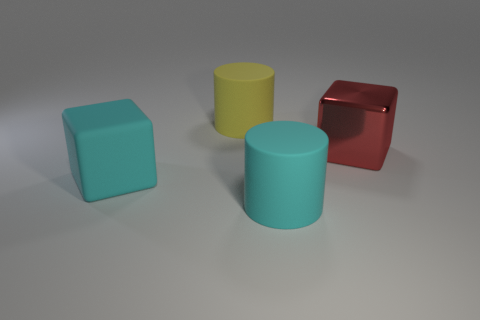Subtract 1 blocks. How many blocks are left? 1 Subtract all brown cylinders. Subtract all green spheres. How many cylinders are left? 2 Subtract all gray cubes. How many yellow cylinders are left? 1 Subtract all red blocks. Subtract all big yellow rubber spheres. How many objects are left? 3 Add 4 large yellow rubber objects. How many large yellow rubber objects are left? 5 Add 1 metallic objects. How many metallic objects exist? 2 Add 3 big cyan rubber things. How many objects exist? 7 Subtract 1 cyan blocks. How many objects are left? 3 